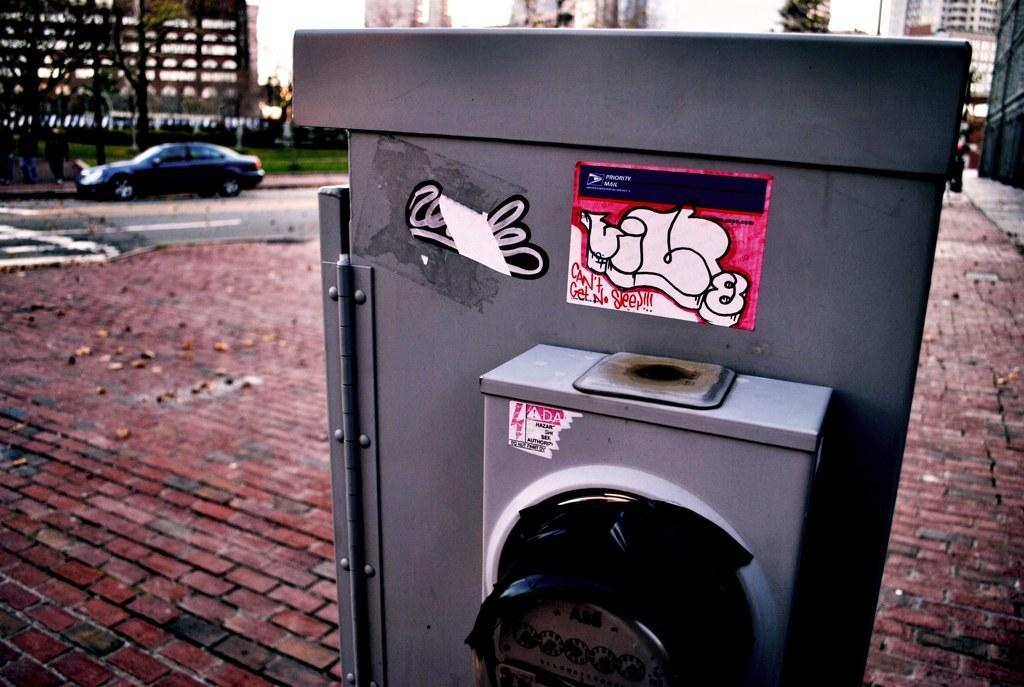<image>
Provide a brief description of the given image. A phrase that says "Can't Get No Sleep" has been written on a metal box. 